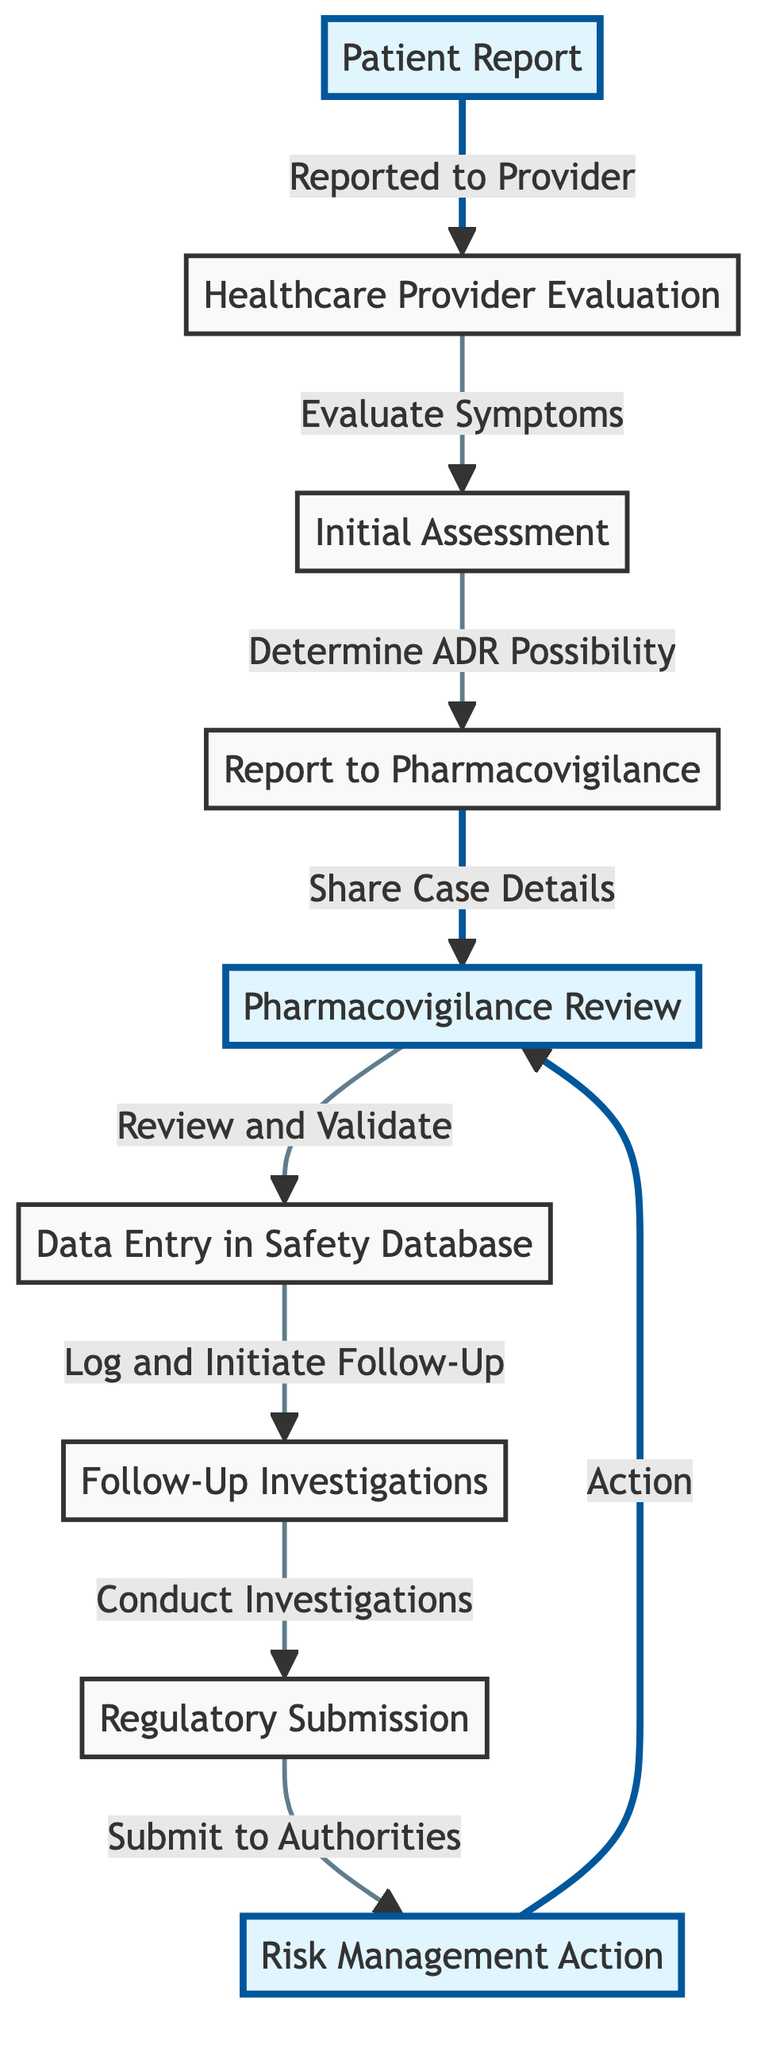What is the first step in the reporting process for adverse drug reactions? The first step shown in the diagram is "Patient Report," which indicates that the process starts when a patient reports an adverse drug reaction.
Answer: Patient Report How many nodes are there in the diagram? By counting each distinct step or element in the flowchart, there are a total of eight nodes representing different stages in the reporting process for adverse drug reactions.
Answer: 8 Which node is directly after "Follow-Up Investigations"? The node that comes directly after "Follow-Up Investigations" is "Regulatory Submission," indicating that after investigations, the next step is to submit the findings to regulatory authorities.
Answer: Regulatory Submission What is the final action taken in the process flow? The last action indicated in the diagram is "Risk Management Action," which shows that the end of the reporting process involves taking necessary actions based on the reviewed data.
Answer: Risk Management Action What relationship exists between "Initial Assessment" and "Report to Pharmacovigilance"? The relationship is defined by the flow indicating that "Initial Assessment" leads to determining the possibility of an adverse drug reaction, which then prompts the reporting of this information to pharmacovigilance.
Answer: Determine ADR Possibility Explain the flow from "Report to Pharmacovigilance" to "Regulatory Submission." After the "Report to Pharmacovigilance" step, which involves sharing case details, the process continues to "Pharmacovigilance Review." Once the review and validation of the report have taken place, the next step proceeds to "Data Entry in Safety Database," followed by "Follow-Up Investigations," and ultimately leading to "Regulatory Submission." Each node represents a sequential progression based on the previous step's evaluations and actions.
Answer: Sequential flow through review, data entry, investigations to submission What specific highlight color is used on nodes with an important role in the process? The nodes with a critical role in the reporting process are highlighted in light blue, as defined by the 'highlight' class in the diagram.
Answer: Light blue Which node initiates the action of sharing case details? The node that initiates the action of sharing case details is "Report to Pharmacovigilance," which details the process of communicating findings to those responsible for monitoring drug safety.
Answer: Report to Pharmacovigilance What step follows the completion of the pharmacovigilance review? Following the completion of the pharmacovigilance review, the next step is "Data Entry in Safety Database," which indicates that validated information is logged for further processing.
Answer: Data Entry in Safety Database 